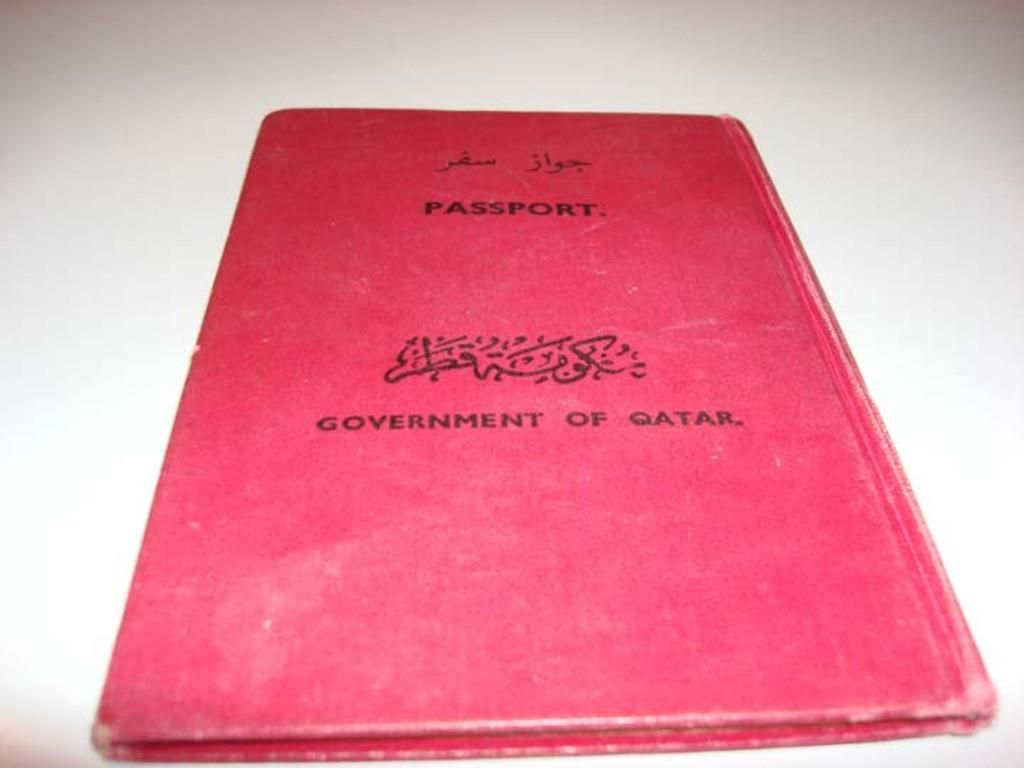<image>
Create a compact narrative representing the image presented. A red passport issued by the government of Qatar. 